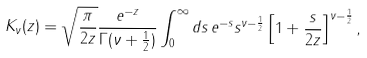<formula> <loc_0><loc_0><loc_500><loc_500>K _ { \nu } ( z ) = \sqrt { \frac { \pi } { 2 z } } \frac { e ^ { - z } } { \Gamma ( \nu + \frac { 1 } { 2 } ) } \int _ { 0 } ^ { \infty } d s \, e ^ { - s } s ^ { \nu - \frac { 1 } { 2 } } \left [ 1 + \frac { s } { 2 z } \right ] ^ { \nu - \frac { 1 } { 2 } } ,</formula> 